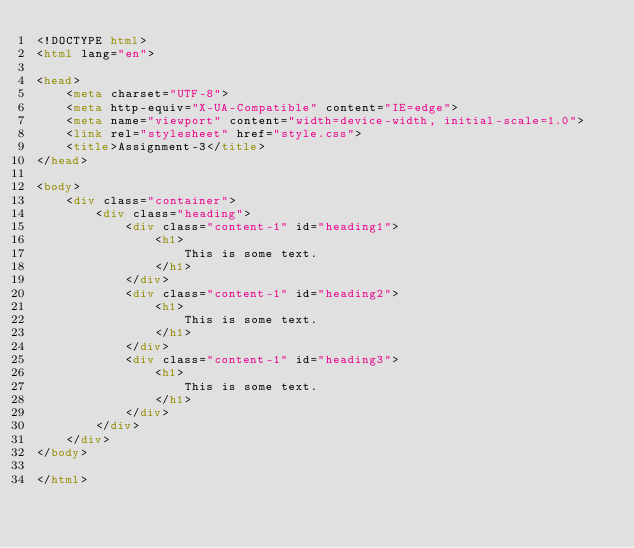<code> <loc_0><loc_0><loc_500><loc_500><_HTML_><!DOCTYPE html>
<html lang="en">

<head>
    <meta charset="UTF-8">
    <meta http-equiv="X-UA-Compatible" content="IE=edge">
    <meta name="viewport" content="width=device-width, initial-scale=1.0">
    <link rel="stylesheet" href="style.css">
    <title>Assignment-3</title>
</head>

<body>
    <div class="container">
        <div class="heading">
            <div class="content-1" id="heading1">
                <h1>
                    This is some text.
                </h1>
            </div>
            <div class="content-1" id="heading2">
                <h1>
                    This is some text.
                </h1>
            </div>
            <div class="content-1" id="heading3">
                <h1>
                    This is some text.
                </h1>
            </div>
        </div>
    </div>
</body>

</html></code> 